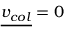<formula> <loc_0><loc_0><loc_500><loc_500>{ \underline { { v _ { c o l } } } } = 0</formula> 